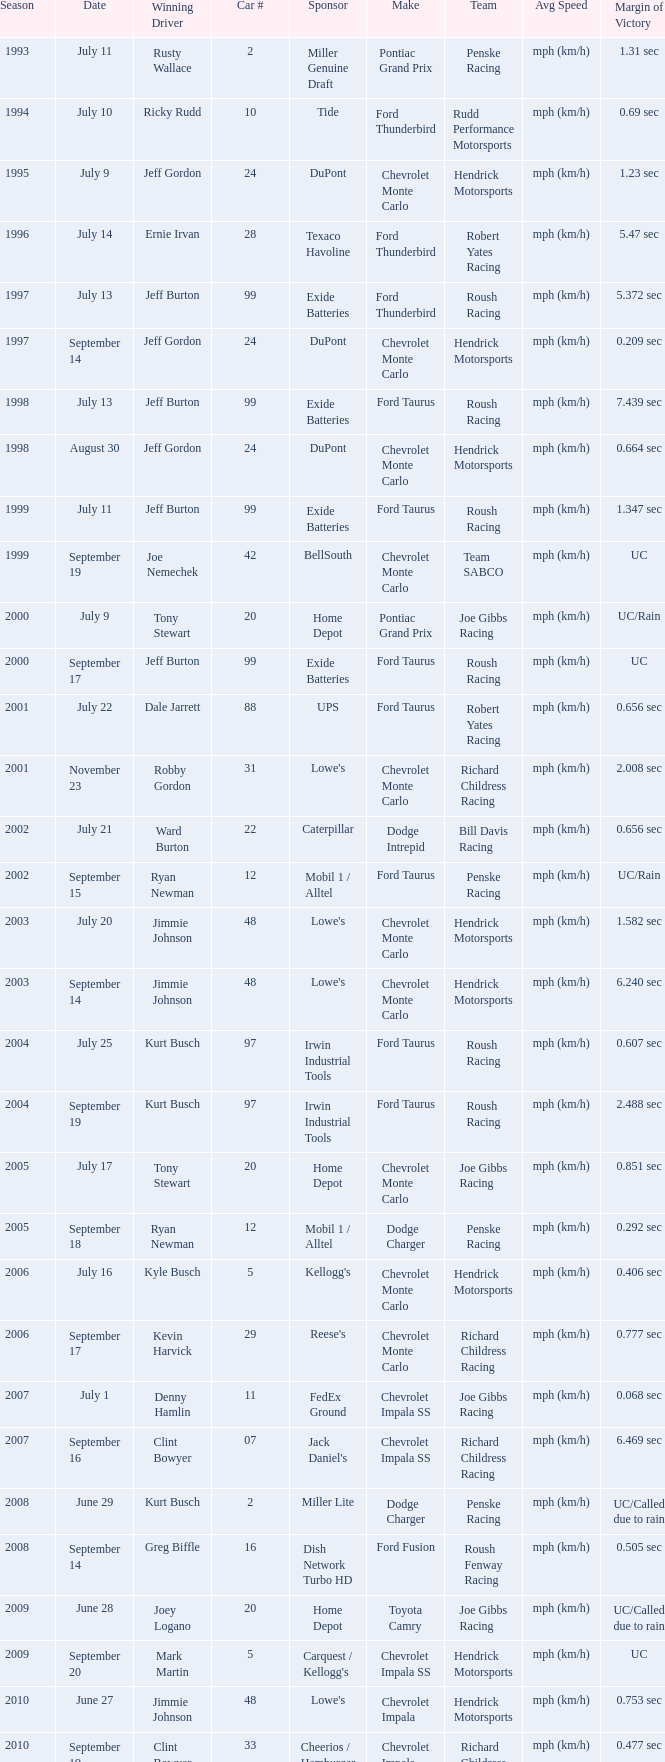What team ran car #24 on August 30? Hendrick Motorsports. 